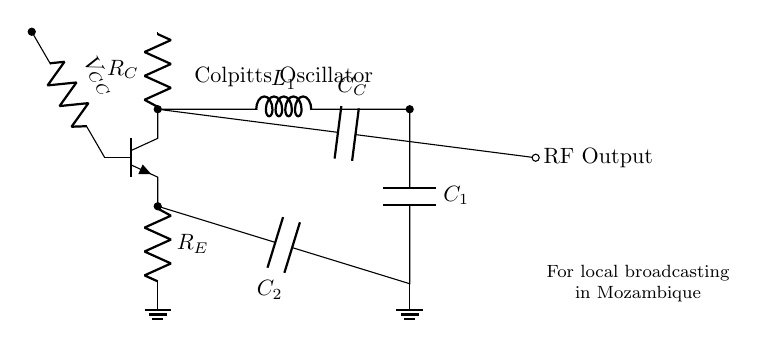What type of oscillator is depicted in the circuit? The circuit is a Colpitts oscillator, which is identified by the specific arrangement of inductors and capacitors for feedback.
Answer: Colpitts What are the values of the capacitors used in the circuit? The circuit includes two capacitors, identified as C1 and C2, but their specific values are not shown; they are simply designated as components in the oscillator.
Answer: C1 and C2 What is the function of the inductor in the circuit? The inductor L1 forms part of the LC tank circuit, which is essential for generating the oscillations at a specific frequency based on its value combined with the capacitors.
Answer: Oscillation generation How many biasing resistors are present in the circuit? There are three biasing resistors: RB, RC, and RE, which are used to set the appropriate operating point for the transistor.
Answer: Three What does the coupling capacitor (C_C) do in the circuit? The coupling capacitor C_C is used to pass the radio frequency output signal while blocking any DC component, allowing AC signals to be transmitted without affecting DC biasing.
Answer: Signal coupling What is the purpose of the ground connections in the circuit? The ground connections provide a common reference point for all voltage levels in the circuit, ensuring stable operation and safety by completing the circuit loop.
Answer: Reference point What is the output of the Colpitts oscillator used for? The output of the Colpitts oscillator is indicated as RF Output, suggesting it is used for transmitting radio frequency signals, possibly for local broadcasting applications.
Answer: Local broadcasting 